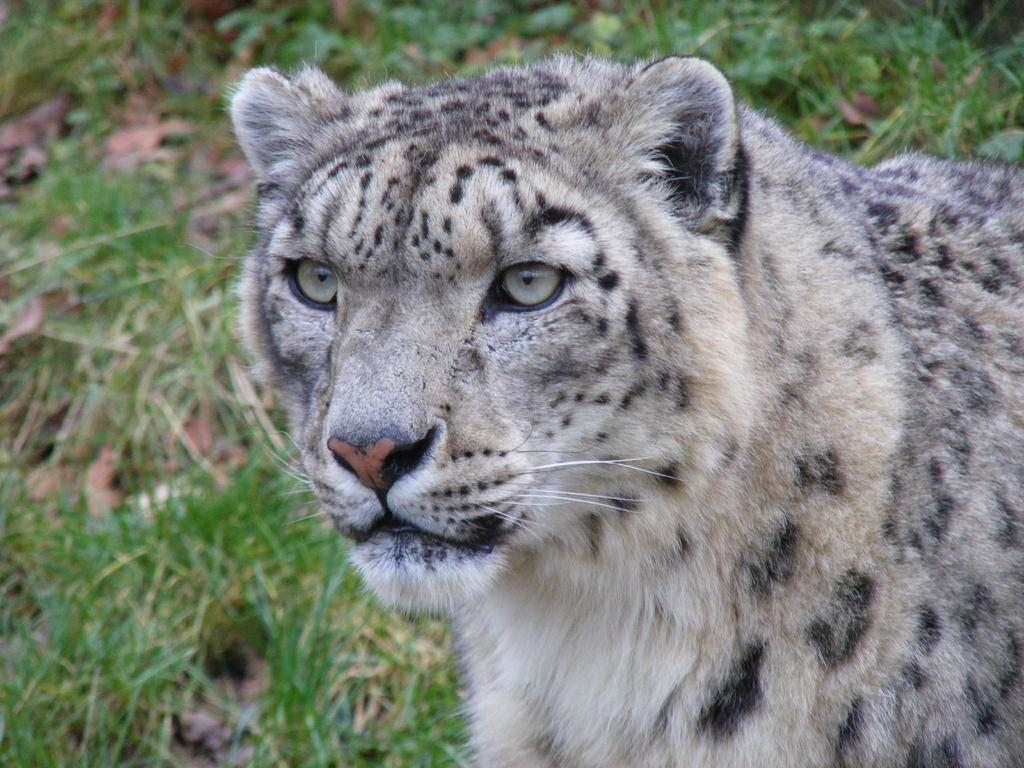What type of animal is in the image? There is a tiger in the image. What type of cake is being served on the railway in the image? There is no cake or railway present in the image; it features a tiger. What book is the tiger reading in the image? There is no book present in the image; it features a tiger. 